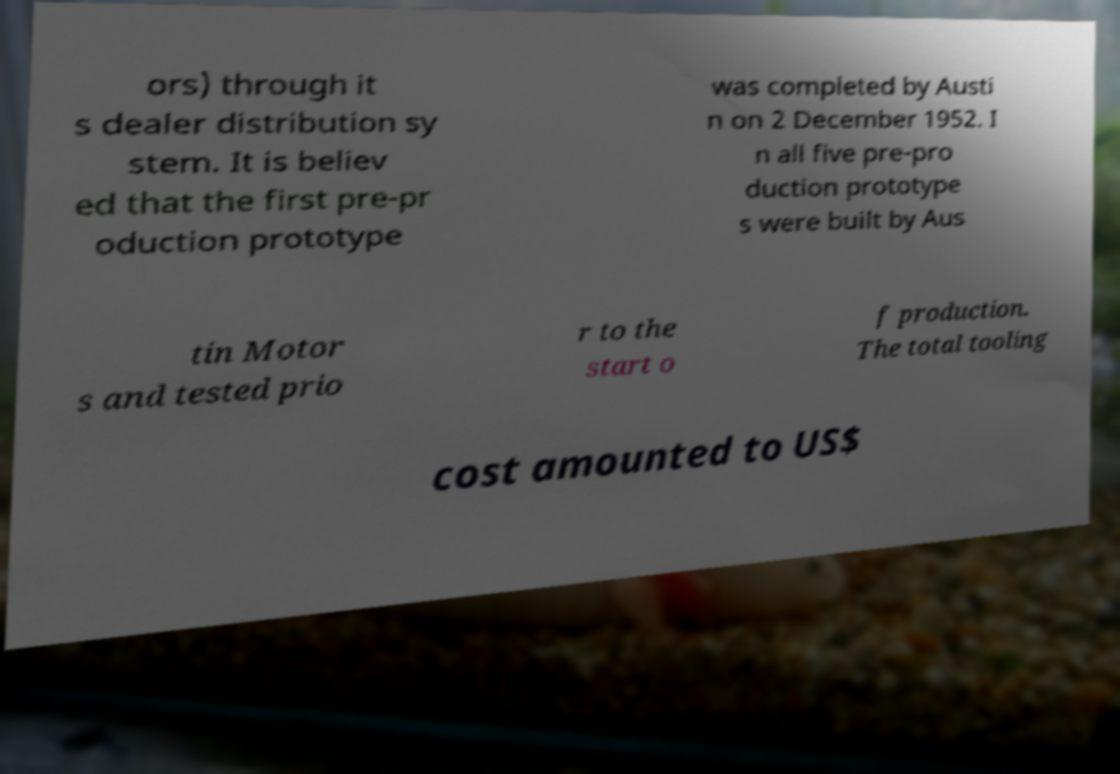For documentation purposes, I need the text within this image transcribed. Could you provide that? ors) through it s dealer distribution sy stem. It is believ ed that the first pre-pr oduction prototype was completed by Austi n on 2 December 1952. I n all five pre-pro duction prototype s were built by Aus tin Motor s and tested prio r to the start o f production. The total tooling cost amounted to US$ 